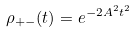Convert formula to latex. <formula><loc_0><loc_0><loc_500><loc_500>\rho _ { + - } ( t ) = e ^ { - 2 A ^ { 2 } t ^ { 2 } }</formula> 